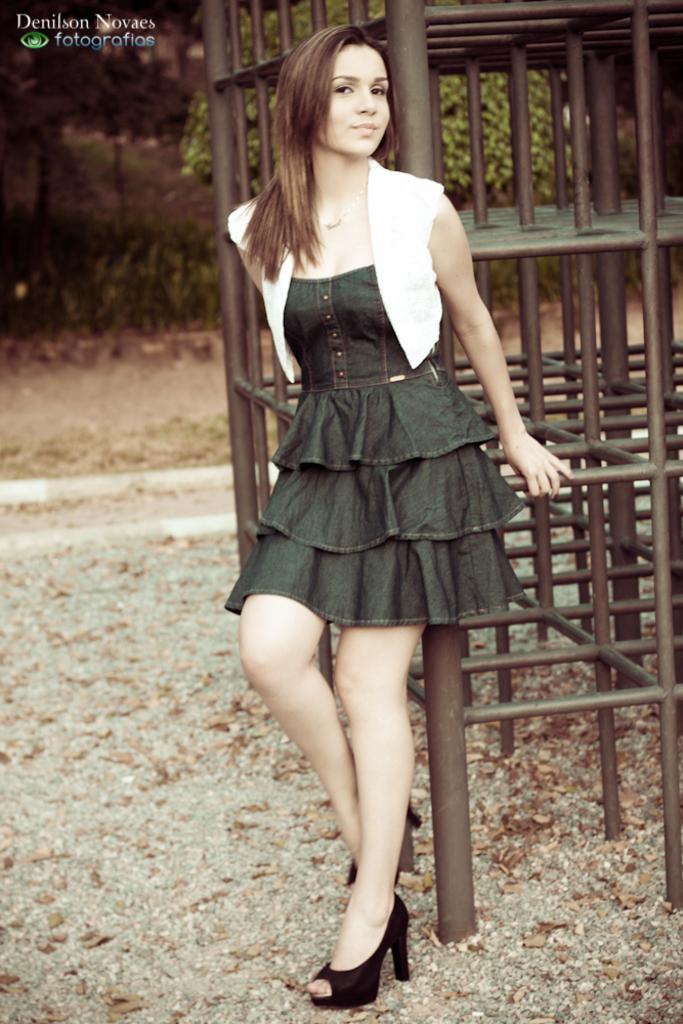Please provide a concise description of this image. In this image image I can see a woman is standing on the ground. In the background, I can see metal object, a tree and leaves on the ground. Here I can see a watermark. 